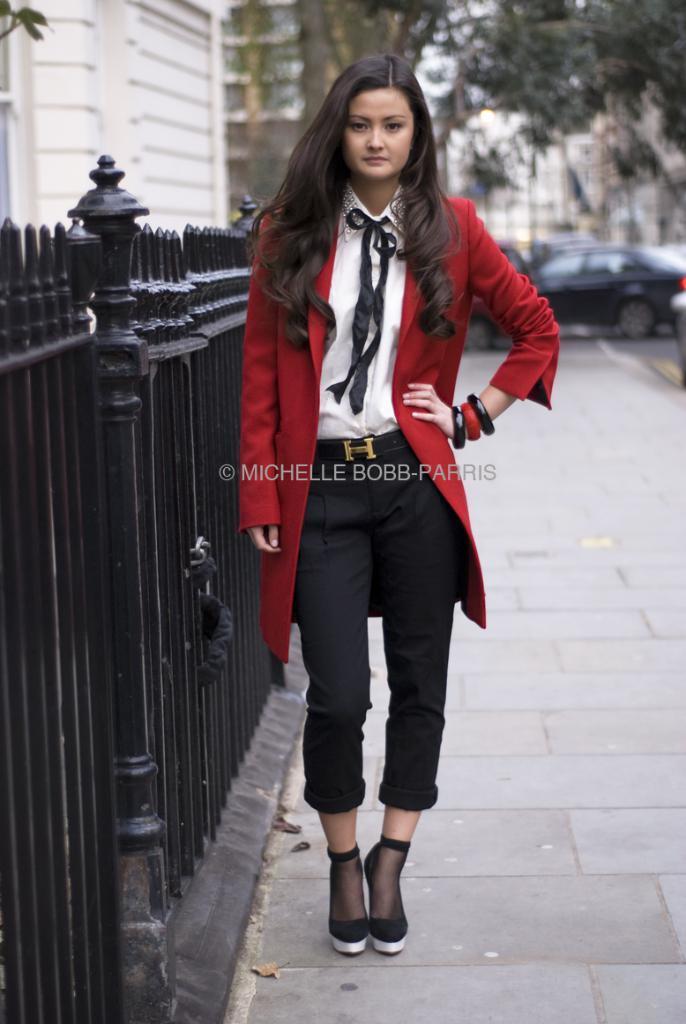How would you summarize this image in a sentence or two? In this image I can see a person standing wearing red color jacket, white color shirt, black pant. I can also see railing in black color, background I can see trees in green color, car in black color and a building in white color. 